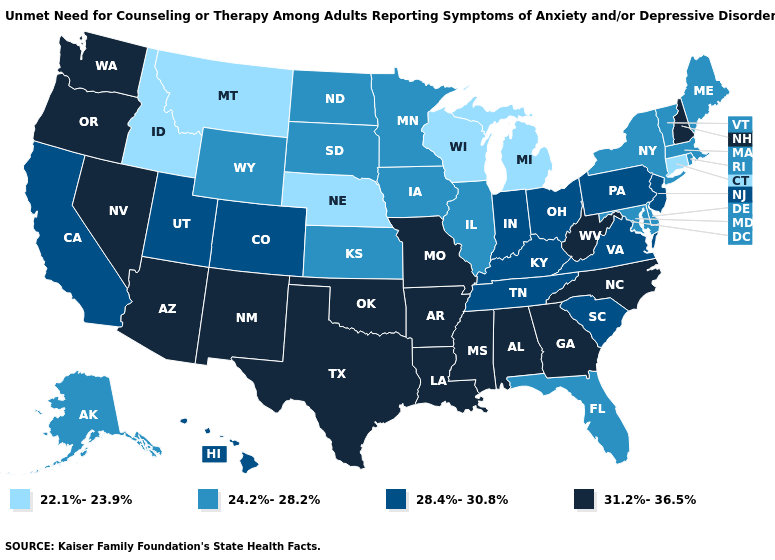Which states have the lowest value in the South?
Write a very short answer. Delaware, Florida, Maryland. Which states have the lowest value in the USA?
Quick response, please. Connecticut, Idaho, Michigan, Montana, Nebraska, Wisconsin. Name the states that have a value in the range 28.4%-30.8%?
Answer briefly. California, Colorado, Hawaii, Indiana, Kentucky, New Jersey, Ohio, Pennsylvania, South Carolina, Tennessee, Utah, Virginia. Does Oklahoma have a higher value than Wisconsin?
Concise answer only. Yes. Name the states that have a value in the range 22.1%-23.9%?
Write a very short answer. Connecticut, Idaho, Michigan, Montana, Nebraska, Wisconsin. Does the map have missing data?
Be succinct. No. Which states hav the highest value in the MidWest?
Give a very brief answer. Missouri. Among the states that border Kentucky , does Missouri have the lowest value?
Write a very short answer. No. Does Oklahoma have the highest value in the South?
Answer briefly. Yes. What is the highest value in the USA?
Give a very brief answer. 31.2%-36.5%. Does Nebraska have the lowest value in the USA?
Keep it brief. Yes. Which states have the highest value in the USA?
Answer briefly. Alabama, Arizona, Arkansas, Georgia, Louisiana, Mississippi, Missouri, Nevada, New Hampshire, New Mexico, North Carolina, Oklahoma, Oregon, Texas, Washington, West Virginia. Name the states that have a value in the range 22.1%-23.9%?
Keep it brief. Connecticut, Idaho, Michigan, Montana, Nebraska, Wisconsin. What is the lowest value in the USA?
Write a very short answer. 22.1%-23.9%. Which states have the lowest value in the MidWest?
Keep it brief. Michigan, Nebraska, Wisconsin. 